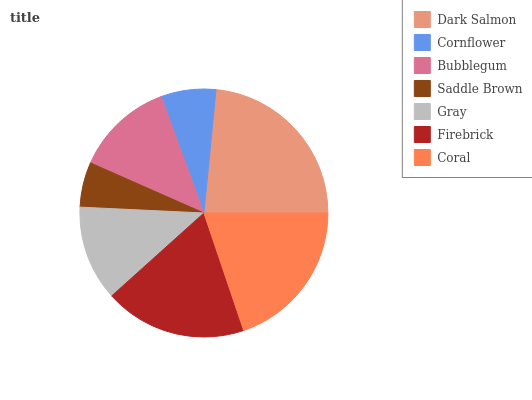Is Saddle Brown the minimum?
Answer yes or no. Yes. Is Dark Salmon the maximum?
Answer yes or no. Yes. Is Cornflower the minimum?
Answer yes or no. No. Is Cornflower the maximum?
Answer yes or no. No. Is Dark Salmon greater than Cornflower?
Answer yes or no. Yes. Is Cornflower less than Dark Salmon?
Answer yes or no. Yes. Is Cornflower greater than Dark Salmon?
Answer yes or no. No. Is Dark Salmon less than Cornflower?
Answer yes or no. No. Is Bubblegum the high median?
Answer yes or no. Yes. Is Bubblegum the low median?
Answer yes or no. Yes. Is Dark Salmon the high median?
Answer yes or no. No. Is Gray the low median?
Answer yes or no. No. 